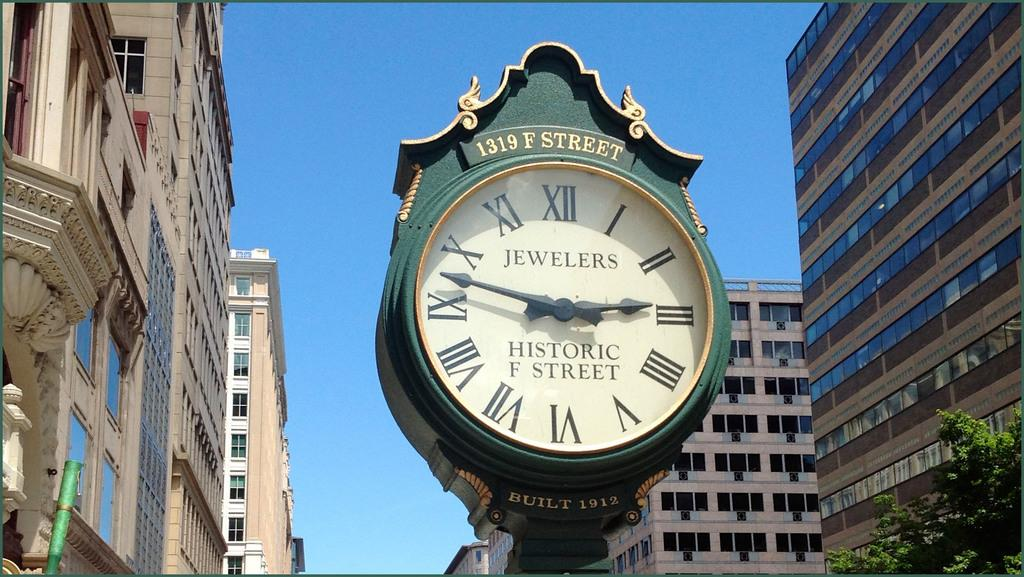<image>
Summarize the visual content of the image. Green and white clock which says Historic F Street on it. 